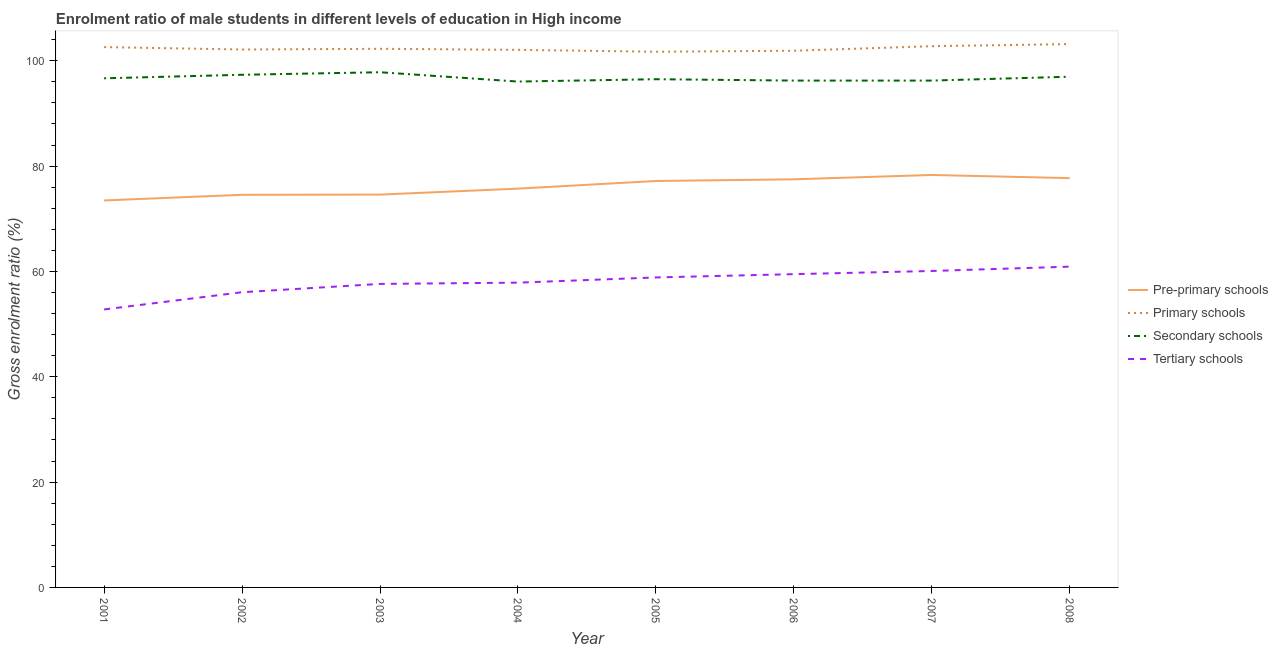Is the number of lines equal to the number of legend labels?
Provide a short and direct response. Yes. What is the gross enrolment ratio(female) in tertiary schools in 2005?
Ensure brevity in your answer.  58.86. Across all years, what is the maximum gross enrolment ratio(female) in secondary schools?
Offer a very short reply. 97.82. Across all years, what is the minimum gross enrolment ratio(female) in tertiary schools?
Your response must be concise. 52.78. In which year was the gross enrolment ratio(female) in pre-primary schools minimum?
Ensure brevity in your answer.  2001. What is the total gross enrolment ratio(female) in tertiary schools in the graph?
Make the answer very short. 463.66. What is the difference between the gross enrolment ratio(female) in pre-primary schools in 2001 and that in 2004?
Make the answer very short. -2.25. What is the difference between the gross enrolment ratio(female) in pre-primary schools in 2004 and the gross enrolment ratio(female) in secondary schools in 2003?
Your answer should be very brief. -22.1. What is the average gross enrolment ratio(female) in primary schools per year?
Make the answer very short. 102.32. In the year 2002, what is the difference between the gross enrolment ratio(female) in tertiary schools and gross enrolment ratio(female) in secondary schools?
Your response must be concise. -41.28. What is the ratio of the gross enrolment ratio(female) in secondary schools in 2001 to that in 2007?
Make the answer very short. 1. What is the difference between the highest and the second highest gross enrolment ratio(female) in secondary schools?
Ensure brevity in your answer.  0.48. What is the difference between the highest and the lowest gross enrolment ratio(female) in primary schools?
Your response must be concise. 1.45. Is it the case that in every year, the sum of the gross enrolment ratio(female) in pre-primary schools and gross enrolment ratio(female) in tertiary schools is greater than the sum of gross enrolment ratio(female) in primary schools and gross enrolment ratio(female) in secondary schools?
Make the answer very short. No. Does the gross enrolment ratio(female) in pre-primary schools monotonically increase over the years?
Provide a short and direct response. No. How many lines are there?
Your response must be concise. 4. Are the values on the major ticks of Y-axis written in scientific E-notation?
Offer a terse response. No. Where does the legend appear in the graph?
Keep it short and to the point. Center right. How many legend labels are there?
Give a very brief answer. 4. What is the title of the graph?
Ensure brevity in your answer.  Enrolment ratio of male students in different levels of education in High income. What is the label or title of the X-axis?
Your answer should be very brief. Year. What is the Gross enrolment ratio (%) in Pre-primary schools in 2001?
Provide a succinct answer. 73.47. What is the Gross enrolment ratio (%) in Primary schools in 2001?
Provide a short and direct response. 102.59. What is the Gross enrolment ratio (%) of Secondary schools in 2001?
Your answer should be very brief. 96.66. What is the Gross enrolment ratio (%) of Tertiary schools in 2001?
Your response must be concise. 52.78. What is the Gross enrolment ratio (%) in Pre-primary schools in 2002?
Provide a short and direct response. 74.55. What is the Gross enrolment ratio (%) of Primary schools in 2002?
Provide a short and direct response. 102.13. What is the Gross enrolment ratio (%) in Secondary schools in 2002?
Ensure brevity in your answer.  97.33. What is the Gross enrolment ratio (%) in Tertiary schools in 2002?
Offer a very short reply. 56.05. What is the Gross enrolment ratio (%) of Pre-primary schools in 2003?
Make the answer very short. 74.58. What is the Gross enrolment ratio (%) of Primary schools in 2003?
Provide a succinct answer. 102.27. What is the Gross enrolment ratio (%) in Secondary schools in 2003?
Give a very brief answer. 97.82. What is the Gross enrolment ratio (%) of Tertiary schools in 2003?
Your answer should be compact. 57.63. What is the Gross enrolment ratio (%) in Pre-primary schools in 2004?
Keep it short and to the point. 75.72. What is the Gross enrolment ratio (%) in Primary schools in 2004?
Offer a very short reply. 102.07. What is the Gross enrolment ratio (%) in Secondary schools in 2004?
Offer a very short reply. 96.05. What is the Gross enrolment ratio (%) in Tertiary schools in 2004?
Provide a short and direct response. 57.87. What is the Gross enrolment ratio (%) in Pre-primary schools in 2005?
Keep it short and to the point. 77.17. What is the Gross enrolment ratio (%) of Primary schools in 2005?
Offer a very short reply. 101.71. What is the Gross enrolment ratio (%) in Secondary schools in 2005?
Provide a short and direct response. 96.49. What is the Gross enrolment ratio (%) in Tertiary schools in 2005?
Offer a terse response. 58.86. What is the Gross enrolment ratio (%) in Pre-primary schools in 2006?
Make the answer very short. 77.49. What is the Gross enrolment ratio (%) of Primary schools in 2006?
Your response must be concise. 101.9. What is the Gross enrolment ratio (%) in Secondary schools in 2006?
Give a very brief answer. 96.23. What is the Gross enrolment ratio (%) in Tertiary schools in 2006?
Provide a short and direct response. 59.48. What is the Gross enrolment ratio (%) of Pre-primary schools in 2007?
Provide a short and direct response. 78.31. What is the Gross enrolment ratio (%) in Primary schools in 2007?
Offer a very short reply. 102.76. What is the Gross enrolment ratio (%) of Secondary schools in 2007?
Keep it short and to the point. 96.23. What is the Gross enrolment ratio (%) of Tertiary schools in 2007?
Make the answer very short. 60.08. What is the Gross enrolment ratio (%) in Pre-primary schools in 2008?
Offer a terse response. 77.71. What is the Gross enrolment ratio (%) of Primary schools in 2008?
Your answer should be compact. 103.16. What is the Gross enrolment ratio (%) of Secondary schools in 2008?
Ensure brevity in your answer.  96.97. What is the Gross enrolment ratio (%) of Tertiary schools in 2008?
Your answer should be compact. 60.91. Across all years, what is the maximum Gross enrolment ratio (%) of Pre-primary schools?
Provide a succinct answer. 78.31. Across all years, what is the maximum Gross enrolment ratio (%) in Primary schools?
Offer a terse response. 103.16. Across all years, what is the maximum Gross enrolment ratio (%) in Secondary schools?
Keep it short and to the point. 97.82. Across all years, what is the maximum Gross enrolment ratio (%) in Tertiary schools?
Give a very brief answer. 60.91. Across all years, what is the minimum Gross enrolment ratio (%) in Pre-primary schools?
Your answer should be compact. 73.47. Across all years, what is the minimum Gross enrolment ratio (%) of Primary schools?
Ensure brevity in your answer.  101.71. Across all years, what is the minimum Gross enrolment ratio (%) of Secondary schools?
Ensure brevity in your answer.  96.05. Across all years, what is the minimum Gross enrolment ratio (%) of Tertiary schools?
Your response must be concise. 52.78. What is the total Gross enrolment ratio (%) of Pre-primary schools in the graph?
Your answer should be compact. 609.01. What is the total Gross enrolment ratio (%) in Primary schools in the graph?
Provide a succinct answer. 818.59. What is the total Gross enrolment ratio (%) in Secondary schools in the graph?
Offer a very short reply. 773.79. What is the total Gross enrolment ratio (%) in Tertiary schools in the graph?
Your answer should be very brief. 463.66. What is the difference between the Gross enrolment ratio (%) in Pre-primary schools in 2001 and that in 2002?
Ensure brevity in your answer.  -1.07. What is the difference between the Gross enrolment ratio (%) of Primary schools in 2001 and that in 2002?
Your response must be concise. 0.46. What is the difference between the Gross enrolment ratio (%) of Secondary schools in 2001 and that in 2002?
Offer a terse response. -0.67. What is the difference between the Gross enrolment ratio (%) in Tertiary schools in 2001 and that in 2002?
Ensure brevity in your answer.  -3.27. What is the difference between the Gross enrolment ratio (%) in Pre-primary schools in 2001 and that in 2003?
Your answer should be very brief. -1.11. What is the difference between the Gross enrolment ratio (%) of Primary schools in 2001 and that in 2003?
Offer a terse response. 0.32. What is the difference between the Gross enrolment ratio (%) in Secondary schools in 2001 and that in 2003?
Keep it short and to the point. -1.15. What is the difference between the Gross enrolment ratio (%) of Tertiary schools in 2001 and that in 2003?
Ensure brevity in your answer.  -4.84. What is the difference between the Gross enrolment ratio (%) of Pre-primary schools in 2001 and that in 2004?
Your answer should be very brief. -2.25. What is the difference between the Gross enrolment ratio (%) of Primary schools in 2001 and that in 2004?
Give a very brief answer. 0.52. What is the difference between the Gross enrolment ratio (%) of Secondary schools in 2001 and that in 2004?
Keep it short and to the point. 0.62. What is the difference between the Gross enrolment ratio (%) in Tertiary schools in 2001 and that in 2004?
Provide a short and direct response. -5.08. What is the difference between the Gross enrolment ratio (%) in Pre-primary schools in 2001 and that in 2005?
Offer a very short reply. -3.69. What is the difference between the Gross enrolment ratio (%) of Primary schools in 2001 and that in 2005?
Your response must be concise. 0.88. What is the difference between the Gross enrolment ratio (%) in Secondary schools in 2001 and that in 2005?
Offer a terse response. 0.17. What is the difference between the Gross enrolment ratio (%) of Tertiary schools in 2001 and that in 2005?
Ensure brevity in your answer.  -6.07. What is the difference between the Gross enrolment ratio (%) in Pre-primary schools in 2001 and that in 2006?
Provide a short and direct response. -4.02. What is the difference between the Gross enrolment ratio (%) in Primary schools in 2001 and that in 2006?
Offer a very short reply. 0.69. What is the difference between the Gross enrolment ratio (%) in Secondary schools in 2001 and that in 2006?
Give a very brief answer. 0.43. What is the difference between the Gross enrolment ratio (%) in Tertiary schools in 2001 and that in 2006?
Your answer should be compact. -6.7. What is the difference between the Gross enrolment ratio (%) of Pre-primary schools in 2001 and that in 2007?
Offer a terse response. -4.84. What is the difference between the Gross enrolment ratio (%) in Primary schools in 2001 and that in 2007?
Make the answer very short. -0.17. What is the difference between the Gross enrolment ratio (%) in Secondary schools in 2001 and that in 2007?
Make the answer very short. 0.43. What is the difference between the Gross enrolment ratio (%) of Tertiary schools in 2001 and that in 2007?
Offer a very short reply. -7.3. What is the difference between the Gross enrolment ratio (%) in Pre-primary schools in 2001 and that in 2008?
Ensure brevity in your answer.  -4.24. What is the difference between the Gross enrolment ratio (%) of Primary schools in 2001 and that in 2008?
Provide a succinct answer. -0.57. What is the difference between the Gross enrolment ratio (%) of Secondary schools in 2001 and that in 2008?
Your answer should be very brief. -0.3. What is the difference between the Gross enrolment ratio (%) of Tertiary schools in 2001 and that in 2008?
Give a very brief answer. -8.12. What is the difference between the Gross enrolment ratio (%) in Pre-primary schools in 2002 and that in 2003?
Ensure brevity in your answer.  -0.04. What is the difference between the Gross enrolment ratio (%) in Primary schools in 2002 and that in 2003?
Make the answer very short. -0.13. What is the difference between the Gross enrolment ratio (%) in Secondary schools in 2002 and that in 2003?
Provide a short and direct response. -0.48. What is the difference between the Gross enrolment ratio (%) of Tertiary schools in 2002 and that in 2003?
Offer a terse response. -1.58. What is the difference between the Gross enrolment ratio (%) of Pre-primary schools in 2002 and that in 2004?
Give a very brief answer. -1.17. What is the difference between the Gross enrolment ratio (%) in Primary schools in 2002 and that in 2004?
Make the answer very short. 0.07. What is the difference between the Gross enrolment ratio (%) of Secondary schools in 2002 and that in 2004?
Provide a short and direct response. 1.29. What is the difference between the Gross enrolment ratio (%) of Tertiary schools in 2002 and that in 2004?
Provide a short and direct response. -1.82. What is the difference between the Gross enrolment ratio (%) of Pre-primary schools in 2002 and that in 2005?
Ensure brevity in your answer.  -2.62. What is the difference between the Gross enrolment ratio (%) in Primary schools in 2002 and that in 2005?
Keep it short and to the point. 0.42. What is the difference between the Gross enrolment ratio (%) of Secondary schools in 2002 and that in 2005?
Offer a very short reply. 0.84. What is the difference between the Gross enrolment ratio (%) in Tertiary schools in 2002 and that in 2005?
Keep it short and to the point. -2.81. What is the difference between the Gross enrolment ratio (%) of Pre-primary schools in 2002 and that in 2006?
Offer a terse response. -2.94. What is the difference between the Gross enrolment ratio (%) in Primary schools in 2002 and that in 2006?
Give a very brief answer. 0.23. What is the difference between the Gross enrolment ratio (%) in Secondary schools in 2002 and that in 2006?
Keep it short and to the point. 1.1. What is the difference between the Gross enrolment ratio (%) in Tertiary schools in 2002 and that in 2006?
Ensure brevity in your answer.  -3.43. What is the difference between the Gross enrolment ratio (%) of Pre-primary schools in 2002 and that in 2007?
Your response must be concise. -3.76. What is the difference between the Gross enrolment ratio (%) in Primary schools in 2002 and that in 2007?
Ensure brevity in your answer.  -0.63. What is the difference between the Gross enrolment ratio (%) of Secondary schools in 2002 and that in 2007?
Give a very brief answer. 1.1. What is the difference between the Gross enrolment ratio (%) in Tertiary schools in 2002 and that in 2007?
Make the answer very short. -4.03. What is the difference between the Gross enrolment ratio (%) of Pre-primary schools in 2002 and that in 2008?
Provide a short and direct response. -3.16. What is the difference between the Gross enrolment ratio (%) in Primary schools in 2002 and that in 2008?
Provide a short and direct response. -1.03. What is the difference between the Gross enrolment ratio (%) of Secondary schools in 2002 and that in 2008?
Ensure brevity in your answer.  0.37. What is the difference between the Gross enrolment ratio (%) in Tertiary schools in 2002 and that in 2008?
Ensure brevity in your answer.  -4.86. What is the difference between the Gross enrolment ratio (%) of Pre-primary schools in 2003 and that in 2004?
Ensure brevity in your answer.  -1.14. What is the difference between the Gross enrolment ratio (%) in Primary schools in 2003 and that in 2004?
Provide a short and direct response. 0.2. What is the difference between the Gross enrolment ratio (%) in Secondary schools in 2003 and that in 2004?
Make the answer very short. 1.77. What is the difference between the Gross enrolment ratio (%) of Tertiary schools in 2003 and that in 2004?
Keep it short and to the point. -0.24. What is the difference between the Gross enrolment ratio (%) in Pre-primary schools in 2003 and that in 2005?
Provide a succinct answer. -2.58. What is the difference between the Gross enrolment ratio (%) in Primary schools in 2003 and that in 2005?
Offer a very short reply. 0.56. What is the difference between the Gross enrolment ratio (%) in Secondary schools in 2003 and that in 2005?
Offer a very short reply. 1.32. What is the difference between the Gross enrolment ratio (%) in Tertiary schools in 2003 and that in 2005?
Your response must be concise. -1.23. What is the difference between the Gross enrolment ratio (%) in Pre-primary schools in 2003 and that in 2006?
Provide a succinct answer. -2.91. What is the difference between the Gross enrolment ratio (%) of Primary schools in 2003 and that in 2006?
Your response must be concise. 0.37. What is the difference between the Gross enrolment ratio (%) in Secondary schools in 2003 and that in 2006?
Provide a succinct answer. 1.58. What is the difference between the Gross enrolment ratio (%) in Tertiary schools in 2003 and that in 2006?
Keep it short and to the point. -1.85. What is the difference between the Gross enrolment ratio (%) in Pre-primary schools in 2003 and that in 2007?
Offer a very short reply. -3.73. What is the difference between the Gross enrolment ratio (%) in Primary schools in 2003 and that in 2007?
Make the answer very short. -0.49. What is the difference between the Gross enrolment ratio (%) of Secondary schools in 2003 and that in 2007?
Your response must be concise. 1.58. What is the difference between the Gross enrolment ratio (%) of Tertiary schools in 2003 and that in 2007?
Give a very brief answer. -2.46. What is the difference between the Gross enrolment ratio (%) of Pre-primary schools in 2003 and that in 2008?
Offer a very short reply. -3.13. What is the difference between the Gross enrolment ratio (%) in Primary schools in 2003 and that in 2008?
Give a very brief answer. -0.89. What is the difference between the Gross enrolment ratio (%) in Secondary schools in 2003 and that in 2008?
Offer a very short reply. 0.85. What is the difference between the Gross enrolment ratio (%) in Tertiary schools in 2003 and that in 2008?
Your answer should be compact. -3.28. What is the difference between the Gross enrolment ratio (%) of Pre-primary schools in 2004 and that in 2005?
Your answer should be very brief. -1.45. What is the difference between the Gross enrolment ratio (%) in Primary schools in 2004 and that in 2005?
Keep it short and to the point. 0.36. What is the difference between the Gross enrolment ratio (%) of Secondary schools in 2004 and that in 2005?
Offer a terse response. -0.45. What is the difference between the Gross enrolment ratio (%) in Tertiary schools in 2004 and that in 2005?
Offer a very short reply. -0.99. What is the difference between the Gross enrolment ratio (%) of Pre-primary schools in 2004 and that in 2006?
Your response must be concise. -1.77. What is the difference between the Gross enrolment ratio (%) of Primary schools in 2004 and that in 2006?
Offer a terse response. 0.17. What is the difference between the Gross enrolment ratio (%) of Secondary schools in 2004 and that in 2006?
Keep it short and to the point. -0.19. What is the difference between the Gross enrolment ratio (%) of Tertiary schools in 2004 and that in 2006?
Provide a succinct answer. -1.61. What is the difference between the Gross enrolment ratio (%) in Pre-primary schools in 2004 and that in 2007?
Provide a succinct answer. -2.59. What is the difference between the Gross enrolment ratio (%) in Primary schools in 2004 and that in 2007?
Ensure brevity in your answer.  -0.7. What is the difference between the Gross enrolment ratio (%) of Secondary schools in 2004 and that in 2007?
Ensure brevity in your answer.  -0.19. What is the difference between the Gross enrolment ratio (%) in Tertiary schools in 2004 and that in 2007?
Offer a very short reply. -2.22. What is the difference between the Gross enrolment ratio (%) in Pre-primary schools in 2004 and that in 2008?
Give a very brief answer. -1.99. What is the difference between the Gross enrolment ratio (%) of Primary schools in 2004 and that in 2008?
Your response must be concise. -1.1. What is the difference between the Gross enrolment ratio (%) of Secondary schools in 2004 and that in 2008?
Offer a terse response. -0.92. What is the difference between the Gross enrolment ratio (%) in Tertiary schools in 2004 and that in 2008?
Keep it short and to the point. -3.04. What is the difference between the Gross enrolment ratio (%) of Pre-primary schools in 2005 and that in 2006?
Make the answer very short. -0.32. What is the difference between the Gross enrolment ratio (%) in Primary schools in 2005 and that in 2006?
Offer a very short reply. -0.19. What is the difference between the Gross enrolment ratio (%) of Secondary schools in 2005 and that in 2006?
Provide a succinct answer. 0.26. What is the difference between the Gross enrolment ratio (%) in Tertiary schools in 2005 and that in 2006?
Provide a succinct answer. -0.62. What is the difference between the Gross enrolment ratio (%) of Pre-primary schools in 2005 and that in 2007?
Give a very brief answer. -1.14. What is the difference between the Gross enrolment ratio (%) of Primary schools in 2005 and that in 2007?
Offer a very short reply. -1.05. What is the difference between the Gross enrolment ratio (%) in Secondary schools in 2005 and that in 2007?
Provide a succinct answer. 0.26. What is the difference between the Gross enrolment ratio (%) of Tertiary schools in 2005 and that in 2007?
Give a very brief answer. -1.23. What is the difference between the Gross enrolment ratio (%) in Pre-primary schools in 2005 and that in 2008?
Your response must be concise. -0.54. What is the difference between the Gross enrolment ratio (%) in Primary schools in 2005 and that in 2008?
Your answer should be compact. -1.45. What is the difference between the Gross enrolment ratio (%) of Secondary schools in 2005 and that in 2008?
Your answer should be very brief. -0.48. What is the difference between the Gross enrolment ratio (%) in Tertiary schools in 2005 and that in 2008?
Make the answer very short. -2.05. What is the difference between the Gross enrolment ratio (%) of Pre-primary schools in 2006 and that in 2007?
Give a very brief answer. -0.82. What is the difference between the Gross enrolment ratio (%) of Primary schools in 2006 and that in 2007?
Ensure brevity in your answer.  -0.86. What is the difference between the Gross enrolment ratio (%) of Secondary schools in 2006 and that in 2007?
Provide a succinct answer. -0. What is the difference between the Gross enrolment ratio (%) of Tertiary schools in 2006 and that in 2007?
Ensure brevity in your answer.  -0.6. What is the difference between the Gross enrolment ratio (%) of Pre-primary schools in 2006 and that in 2008?
Offer a terse response. -0.22. What is the difference between the Gross enrolment ratio (%) of Primary schools in 2006 and that in 2008?
Your answer should be compact. -1.26. What is the difference between the Gross enrolment ratio (%) of Secondary schools in 2006 and that in 2008?
Your response must be concise. -0.74. What is the difference between the Gross enrolment ratio (%) in Tertiary schools in 2006 and that in 2008?
Ensure brevity in your answer.  -1.43. What is the difference between the Gross enrolment ratio (%) in Pre-primary schools in 2007 and that in 2008?
Make the answer very short. 0.6. What is the difference between the Gross enrolment ratio (%) of Primary schools in 2007 and that in 2008?
Your answer should be compact. -0.4. What is the difference between the Gross enrolment ratio (%) in Secondary schools in 2007 and that in 2008?
Ensure brevity in your answer.  -0.73. What is the difference between the Gross enrolment ratio (%) of Tertiary schools in 2007 and that in 2008?
Offer a terse response. -0.82. What is the difference between the Gross enrolment ratio (%) of Pre-primary schools in 2001 and the Gross enrolment ratio (%) of Primary schools in 2002?
Your answer should be compact. -28.66. What is the difference between the Gross enrolment ratio (%) in Pre-primary schools in 2001 and the Gross enrolment ratio (%) in Secondary schools in 2002?
Keep it short and to the point. -23.86. What is the difference between the Gross enrolment ratio (%) in Pre-primary schools in 2001 and the Gross enrolment ratio (%) in Tertiary schools in 2002?
Make the answer very short. 17.42. What is the difference between the Gross enrolment ratio (%) of Primary schools in 2001 and the Gross enrolment ratio (%) of Secondary schools in 2002?
Your answer should be compact. 5.25. What is the difference between the Gross enrolment ratio (%) of Primary schools in 2001 and the Gross enrolment ratio (%) of Tertiary schools in 2002?
Provide a succinct answer. 46.54. What is the difference between the Gross enrolment ratio (%) of Secondary schools in 2001 and the Gross enrolment ratio (%) of Tertiary schools in 2002?
Your answer should be very brief. 40.61. What is the difference between the Gross enrolment ratio (%) in Pre-primary schools in 2001 and the Gross enrolment ratio (%) in Primary schools in 2003?
Give a very brief answer. -28.79. What is the difference between the Gross enrolment ratio (%) of Pre-primary schools in 2001 and the Gross enrolment ratio (%) of Secondary schools in 2003?
Give a very brief answer. -24.34. What is the difference between the Gross enrolment ratio (%) in Pre-primary schools in 2001 and the Gross enrolment ratio (%) in Tertiary schools in 2003?
Ensure brevity in your answer.  15.85. What is the difference between the Gross enrolment ratio (%) in Primary schools in 2001 and the Gross enrolment ratio (%) in Secondary schools in 2003?
Make the answer very short. 4.77. What is the difference between the Gross enrolment ratio (%) of Primary schools in 2001 and the Gross enrolment ratio (%) of Tertiary schools in 2003?
Offer a very short reply. 44.96. What is the difference between the Gross enrolment ratio (%) of Secondary schools in 2001 and the Gross enrolment ratio (%) of Tertiary schools in 2003?
Provide a succinct answer. 39.04. What is the difference between the Gross enrolment ratio (%) of Pre-primary schools in 2001 and the Gross enrolment ratio (%) of Primary schools in 2004?
Your response must be concise. -28.59. What is the difference between the Gross enrolment ratio (%) in Pre-primary schools in 2001 and the Gross enrolment ratio (%) in Secondary schools in 2004?
Keep it short and to the point. -22.57. What is the difference between the Gross enrolment ratio (%) of Pre-primary schools in 2001 and the Gross enrolment ratio (%) of Tertiary schools in 2004?
Ensure brevity in your answer.  15.61. What is the difference between the Gross enrolment ratio (%) in Primary schools in 2001 and the Gross enrolment ratio (%) in Secondary schools in 2004?
Make the answer very short. 6.54. What is the difference between the Gross enrolment ratio (%) in Primary schools in 2001 and the Gross enrolment ratio (%) in Tertiary schools in 2004?
Give a very brief answer. 44.72. What is the difference between the Gross enrolment ratio (%) in Secondary schools in 2001 and the Gross enrolment ratio (%) in Tertiary schools in 2004?
Provide a succinct answer. 38.8. What is the difference between the Gross enrolment ratio (%) of Pre-primary schools in 2001 and the Gross enrolment ratio (%) of Primary schools in 2005?
Make the answer very short. -28.23. What is the difference between the Gross enrolment ratio (%) in Pre-primary schools in 2001 and the Gross enrolment ratio (%) in Secondary schools in 2005?
Keep it short and to the point. -23.02. What is the difference between the Gross enrolment ratio (%) in Pre-primary schools in 2001 and the Gross enrolment ratio (%) in Tertiary schools in 2005?
Your response must be concise. 14.62. What is the difference between the Gross enrolment ratio (%) of Primary schools in 2001 and the Gross enrolment ratio (%) of Secondary schools in 2005?
Provide a short and direct response. 6.1. What is the difference between the Gross enrolment ratio (%) in Primary schools in 2001 and the Gross enrolment ratio (%) in Tertiary schools in 2005?
Provide a succinct answer. 43.73. What is the difference between the Gross enrolment ratio (%) of Secondary schools in 2001 and the Gross enrolment ratio (%) of Tertiary schools in 2005?
Provide a succinct answer. 37.81. What is the difference between the Gross enrolment ratio (%) in Pre-primary schools in 2001 and the Gross enrolment ratio (%) in Primary schools in 2006?
Ensure brevity in your answer.  -28.42. What is the difference between the Gross enrolment ratio (%) of Pre-primary schools in 2001 and the Gross enrolment ratio (%) of Secondary schools in 2006?
Give a very brief answer. -22.76. What is the difference between the Gross enrolment ratio (%) of Pre-primary schools in 2001 and the Gross enrolment ratio (%) of Tertiary schools in 2006?
Offer a terse response. 13.99. What is the difference between the Gross enrolment ratio (%) in Primary schools in 2001 and the Gross enrolment ratio (%) in Secondary schools in 2006?
Keep it short and to the point. 6.36. What is the difference between the Gross enrolment ratio (%) of Primary schools in 2001 and the Gross enrolment ratio (%) of Tertiary schools in 2006?
Offer a terse response. 43.11. What is the difference between the Gross enrolment ratio (%) in Secondary schools in 2001 and the Gross enrolment ratio (%) in Tertiary schools in 2006?
Your response must be concise. 37.18. What is the difference between the Gross enrolment ratio (%) of Pre-primary schools in 2001 and the Gross enrolment ratio (%) of Primary schools in 2007?
Offer a very short reply. -29.29. What is the difference between the Gross enrolment ratio (%) of Pre-primary schools in 2001 and the Gross enrolment ratio (%) of Secondary schools in 2007?
Offer a very short reply. -22.76. What is the difference between the Gross enrolment ratio (%) of Pre-primary schools in 2001 and the Gross enrolment ratio (%) of Tertiary schools in 2007?
Your answer should be compact. 13.39. What is the difference between the Gross enrolment ratio (%) in Primary schools in 2001 and the Gross enrolment ratio (%) in Secondary schools in 2007?
Offer a very short reply. 6.36. What is the difference between the Gross enrolment ratio (%) in Primary schools in 2001 and the Gross enrolment ratio (%) in Tertiary schools in 2007?
Make the answer very short. 42.51. What is the difference between the Gross enrolment ratio (%) in Secondary schools in 2001 and the Gross enrolment ratio (%) in Tertiary schools in 2007?
Keep it short and to the point. 36.58. What is the difference between the Gross enrolment ratio (%) in Pre-primary schools in 2001 and the Gross enrolment ratio (%) in Primary schools in 2008?
Offer a terse response. -29.69. What is the difference between the Gross enrolment ratio (%) in Pre-primary schools in 2001 and the Gross enrolment ratio (%) in Secondary schools in 2008?
Provide a short and direct response. -23.49. What is the difference between the Gross enrolment ratio (%) of Pre-primary schools in 2001 and the Gross enrolment ratio (%) of Tertiary schools in 2008?
Provide a short and direct response. 12.57. What is the difference between the Gross enrolment ratio (%) of Primary schools in 2001 and the Gross enrolment ratio (%) of Secondary schools in 2008?
Keep it short and to the point. 5.62. What is the difference between the Gross enrolment ratio (%) of Primary schools in 2001 and the Gross enrolment ratio (%) of Tertiary schools in 2008?
Make the answer very short. 41.68. What is the difference between the Gross enrolment ratio (%) in Secondary schools in 2001 and the Gross enrolment ratio (%) in Tertiary schools in 2008?
Offer a very short reply. 35.76. What is the difference between the Gross enrolment ratio (%) of Pre-primary schools in 2002 and the Gross enrolment ratio (%) of Primary schools in 2003?
Give a very brief answer. -27.72. What is the difference between the Gross enrolment ratio (%) of Pre-primary schools in 2002 and the Gross enrolment ratio (%) of Secondary schools in 2003?
Provide a short and direct response. -23.27. What is the difference between the Gross enrolment ratio (%) in Pre-primary schools in 2002 and the Gross enrolment ratio (%) in Tertiary schools in 2003?
Offer a very short reply. 16.92. What is the difference between the Gross enrolment ratio (%) of Primary schools in 2002 and the Gross enrolment ratio (%) of Secondary schools in 2003?
Your answer should be compact. 4.32. What is the difference between the Gross enrolment ratio (%) in Primary schools in 2002 and the Gross enrolment ratio (%) in Tertiary schools in 2003?
Offer a very short reply. 44.51. What is the difference between the Gross enrolment ratio (%) in Secondary schools in 2002 and the Gross enrolment ratio (%) in Tertiary schools in 2003?
Keep it short and to the point. 39.71. What is the difference between the Gross enrolment ratio (%) of Pre-primary schools in 2002 and the Gross enrolment ratio (%) of Primary schools in 2004?
Ensure brevity in your answer.  -27.52. What is the difference between the Gross enrolment ratio (%) in Pre-primary schools in 2002 and the Gross enrolment ratio (%) in Secondary schools in 2004?
Your response must be concise. -21.5. What is the difference between the Gross enrolment ratio (%) in Pre-primary schools in 2002 and the Gross enrolment ratio (%) in Tertiary schools in 2004?
Make the answer very short. 16.68. What is the difference between the Gross enrolment ratio (%) of Primary schools in 2002 and the Gross enrolment ratio (%) of Secondary schools in 2004?
Make the answer very short. 6.09. What is the difference between the Gross enrolment ratio (%) in Primary schools in 2002 and the Gross enrolment ratio (%) in Tertiary schools in 2004?
Give a very brief answer. 44.27. What is the difference between the Gross enrolment ratio (%) of Secondary schools in 2002 and the Gross enrolment ratio (%) of Tertiary schools in 2004?
Provide a succinct answer. 39.47. What is the difference between the Gross enrolment ratio (%) in Pre-primary schools in 2002 and the Gross enrolment ratio (%) in Primary schools in 2005?
Your answer should be very brief. -27.16. What is the difference between the Gross enrolment ratio (%) in Pre-primary schools in 2002 and the Gross enrolment ratio (%) in Secondary schools in 2005?
Your answer should be very brief. -21.95. What is the difference between the Gross enrolment ratio (%) of Pre-primary schools in 2002 and the Gross enrolment ratio (%) of Tertiary schools in 2005?
Provide a succinct answer. 15.69. What is the difference between the Gross enrolment ratio (%) in Primary schools in 2002 and the Gross enrolment ratio (%) in Secondary schools in 2005?
Your answer should be compact. 5.64. What is the difference between the Gross enrolment ratio (%) in Primary schools in 2002 and the Gross enrolment ratio (%) in Tertiary schools in 2005?
Offer a terse response. 43.28. What is the difference between the Gross enrolment ratio (%) of Secondary schools in 2002 and the Gross enrolment ratio (%) of Tertiary schools in 2005?
Your answer should be very brief. 38.48. What is the difference between the Gross enrolment ratio (%) in Pre-primary schools in 2002 and the Gross enrolment ratio (%) in Primary schools in 2006?
Offer a very short reply. -27.35. What is the difference between the Gross enrolment ratio (%) in Pre-primary schools in 2002 and the Gross enrolment ratio (%) in Secondary schools in 2006?
Provide a succinct answer. -21.69. What is the difference between the Gross enrolment ratio (%) of Pre-primary schools in 2002 and the Gross enrolment ratio (%) of Tertiary schools in 2006?
Offer a terse response. 15.07. What is the difference between the Gross enrolment ratio (%) of Primary schools in 2002 and the Gross enrolment ratio (%) of Secondary schools in 2006?
Provide a succinct answer. 5.9. What is the difference between the Gross enrolment ratio (%) of Primary schools in 2002 and the Gross enrolment ratio (%) of Tertiary schools in 2006?
Provide a short and direct response. 42.65. What is the difference between the Gross enrolment ratio (%) in Secondary schools in 2002 and the Gross enrolment ratio (%) in Tertiary schools in 2006?
Make the answer very short. 37.85. What is the difference between the Gross enrolment ratio (%) in Pre-primary schools in 2002 and the Gross enrolment ratio (%) in Primary schools in 2007?
Your response must be concise. -28.22. What is the difference between the Gross enrolment ratio (%) in Pre-primary schools in 2002 and the Gross enrolment ratio (%) in Secondary schools in 2007?
Offer a terse response. -21.69. What is the difference between the Gross enrolment ratio (%) of Pre-primary schools in 2002 and the Gross enrolment ratio (%) of Tertiary schools in 2007?
Offer a terse response. 14.46. What is the difference between the Gross enrolment ratio (%) in Primary schools in 2002 and the Gross enrolment ratio (%) in Secondary schools in 2007?
Give a very brief answer. 5.9. What is the difference between the Gross enrolment ratio (%) in Primary schools in 2002 and the Gross enrolment ratio (%) in Tertiary schools in 2007?
Keep it short and to the point. 42.05. What is the difference between the Gross enrolment ratio (%) in Secondary schools in 2002 and the Gross enrolment ratio (%) in Tertiary schools in 2007?
Your answer should be very brief. 37.25. What is the difference between the Gross enrolment ratio (%) of Pre-primary schools in 2002 and the Gross enrolment ratio (%) of Primary schools in 2008?
Your response must be concise. -28.61. What is the difference between the Gross enrolment ratio (%) of Pre-primary schools in 2002 and the Gross enrolment ratio (%) of Secondary schools in 2008?
Your answer should be very brief. -22.42. What is the difference between the Gross enrolment ratio (%) in Pre-primary schools in 2002 and the Gross enrolment ratio (%) in Tertiary schools in 2008?
Ensure brevity in your answer.  13.64. What is the difference between the Gross enrolment ratio (%) in Primary schools in 2002 and the Gross enrolment ratio (%) in Secondary schools in 2008?
Your answer should be very brief. 5.16. What is the difference between the Gross enrolment ratio (%) in Primary schools in 2002 and the Gross enrolment ratio (%) in Tertiary schools in 2008?
Your answer should be compact. 41.23. What is the difference between the Gross enrolment ratio (%) of Secondary schools in 2002 and the Gross enrolment ratio (%) of Tertiary schools in 2008?
Your response must be concise. 36.43. What is the difference between the Gross enrolment ratio (%) of Pre-primary schools in 2003 and the Gross enrolment ratio (%) of Primary schools in 2004?
Provide a succinct answer. -27.48. What is the difference between the Gross enrolment ratio (%) in Pre-primary schools in 2003 and the Gross enrolment ratio (%) in Secondary schools in 2004?
Provide a succinct answer. -21.46. What is the difference between the Gross enrolment ratio (%) in Pre-primary schools in 2003 and the Gross enrolment ratio (%) in Tertiary schools in 2004?
Your answer should be very brief. 16.72. What is the difference between the Gross enrolment ratio (%) in Primary schools in 2003 and the Gross enrolment ratio (%) in Secondary schools in 2004?
Provide a succinct answer. 6.22. What is the difference between the Gross enrolment ratio (%) of Primary schools in 2003 and the Gross enrolment ratio (%) of Tertiary schools in 2004?
Offer a terse response. 44.4. What is the difference between the Gross enrolment ratio (%) of Secondary schools in 2003 and the Gross enrolment ratio (%) of Tertiary schools in 2004?
Make the answer very short. 39.95. What is the difference between the Gross enrolment ratio (%) in Pre-primary schools in 2003 and the Gross enrolment ratio (%) in Primary schools in 2005?
Offer a very short reply. -27.12. What is the difference between the Gross enrolment ratio (%) in Pre-primary schools in 2003 and the Gross enrolment ratio (%) in Secondary schools in 2005?
Give a very brief answer. -21.91. What is the difference between the Gross enrolment ratio (%) of Pre-primary schools in 2003 and the Gross enrolment ratio (%) of Tertiary schools in 2005?
Provide a succinct answer. 15.73. What is the difference between the Gross enrolment ratio (%) in Primary schools in 2003 and the Gross enrolment ratio (%) in Secondary schools in 2005?
Keep it short and to the point. 5.78. What is the difference between the Gross enrolment ratio (%) of Primary schools in 2003 and the Gross enrolment ratio (%) of Tertiary schools in 2005?
Your answer should be compact. 43.41. What is the difference between the Gross enrolment ratio (%) in Secondary schools in 2003 and the Gross enrolment ratio (%) in Tertiary schools in 2005?
Offer a very short reply. 38.96. What is the difference between the Gross enrolment ratio (%) of Pre-primary schools in 2003 and the Gross enrolment ratio (%) of Primary schools in 2006?
Your answer should be compact. -27.31. What is the difference between the Gross enrolment ratio (%) in Pre-primary schools in 2003 and the Gross enrolment ratio (%) in Secondary schools in 2006?
Offer a very short reply. -21.65. What is the difference between the Gross enrolment ratio (%) of Pre-primary schools in 2003 and the Gross enrolment ratio (%) of Tertiary schools in 2006?
Give a very brief answer. 15.1. What is the difference between the Gross enrolment ratio (%) of Primary schools in 2003 and the Gross enrolment ratio (%) of Secondary schools in 2006?
Offer a very short reply. 6.04. What is the difference between the Gross enrolment ratio (%) in Primary schools in 2003 and the Gross enrolment ratio (%) in Tertiary schools in 2006?
Ensure brevity in your answer.  42.79. What is the difference between the Gross enrolment ratio (%) in Secondary schools in 2003 and the Gross enrolment ratio (%) in Tertiary schools in 2006?
Provide a succinct answer. 38.34. What is the difference between the Gross enrolment ratio (%) in Pre-primary schools in 2003 and the Gross enrolment ratio (%) in Primary schools in 2007?
Make the answer very short. -28.18. What is the difference between the Gross enrolment ratio (%) of Pre-primary schools in 2003 and the Gross enrolment ratio (%) of Secondary schools in 2007?
Keep it short and to the point. -21.65. What is the difference between the Gross enrolment ratio (%) in Pre-primary schools in 2003 and the Gross enrolment ratio (%) in Tertiary schools in 2007?
Give a very brief answer. 14.5. What is the difference between the Gross enrolment ratio (%) in Primary schools in 2003 and the Gross enrolment ratio (%) in Secondary schools in 2007?
Your answer should be very brief. 6.03. What is the difference between the Gross enrolment ratio (%) of Primary schools in 2003 and the Gross enrolment ratio (%) of Tertiary schools in 2007?
Offer a terse response. 42.18. What is the difference between the Gross enrolment ratio (%) of Secondary schools in 2003 and the Gross enrolment ratio (%) of Tertiary schools in 2007?
Provide a short and direct response. 37.73. What is the difference between the Gross enrolment ratio (%) of Pre-primary schools in 2003 and the Gross enrolment ratio (%) of Primary schools in 2008?
Ensure brevity in your answer.  -28.58. What is the difference between the Gross enrolment ratio (%) in Pre-primary schools in 2003 and the Gross enrolment ratio (%) in Secondary schools in 2008?
Offer a very short reply. -22.38. What is the difference between the Gross enrolment ratio (%) of Pre-primary schools in 2003 and the Gross enrolment ratio (%) of Tertiary schools in 2008?
Offer a terse response. 13.68. What is the difference between the Gross enrolment ratio (%) in Primary schools in 2003 and the Gross enrolment ratio (%) in Secondary schools in 2008?
Ensure brevity in your answer.  5.3. What is the difference between the Gross enrolment ratio (%) in Primary schools in 2003 and the Gross enrolment ratio (%) in Tertiary schools in 2008?
Your answer should be very brief. 41.36. What is the difference between the Gross enrolment ratio (%) in Secondary schools in 2003 and the Gross enrolment ratio (%) in Tertiary schools in 2008?
Make the answer very short. 36.91. What is the difference between the Gross enrolment ratio (%) of Pre-primary schools in 2004 and the Gross enrolment ratio (%) of Primary schools in 2005?
Offer a very short reply. -25.99. What is the difference between the Gross enrolment ratio (%) of Pre-primary schools in 2004 and the Gross enrolment ratio (%) of Secondary schools in 2005?
Keep it short and to the point. -20.77. What is the difference between the Gross enrolment ratio (%) of Pre-primary schools in 2004 and the Gross enrolment ratio (%) of Tertiary schools in 2005?
Your response must be concise. 16.86. What is the difference between the Gross enrolment ratio (%) of Primary schools in 2004 and the Gross enrolment ratio (%) of Secondary schools in 2005?
Provide a succinct answer. 5.57. What is the difference between the Gross enrolment ratio (%) of Primary schools in 2004 and the Gross enrolment ratio (%) of Tertiary schools in 2005?
Offer a terse response. 43.21. What is the difference between the Gross enrolment ratio (%) in Secondary schools in 2004 and the Gross enrolment ratio (%) in Tertiary schools in 2005?
Make the answer very short. 37.19. What is the difference between the Gross enrolment ratio (%) of Pre-primary schools in 2004 and the Gross enrolment ratio (%) of Primary schools in 2006?
Give a very brief answer. -26.18. What is the difference between the Gross enrolment ratio (%) in Pre-primary schools in 2004 and the Gross enrolment ratio (%) in Secondary schools in 2006?
Provide a short and direct response. -20.51. What is the difference between the Gross enrolment ratio (%) of Pre-primary schools in 2004 and the Gross enrolment ratio (%) of Tertiary schools in 2006?
Keep it short and to the point. 16.24. What is the difference between the Gross enrolment ratio (%) of Primary schools in 2004 and the Gross enrolment ratio (%) of Secondary schools in 2006?
Keep it short and to the point. 5.83. What is the difference between the Gross enrolment ratio (%) in Primary schools in 2004 and the Gross enrolment ratio (%) in Tertiary schools in 2006?
Keep it short and to the point. 42.59. What is the difference between the Gross enrolment ratio (%) of Secondary schools in 2004 and the Gross enrolment ratio (%) of Tertiary schools in 2006?
Your answer should be very brief. 36.57. What is the difference between the Gross enrolment ratio (%) of Pre-primary schools in 2004 and the Gross enrolment ratio (%) of Primary schools in 2007?
Make the answer very short. -27.04. What is the difference between the Gross enrolment ratio (%) of Pre-primary schools in 2004 and the Gross enrolment ratio (%) of Secondary schools in 2007?
Make the answer very short. -20.51. What is the difference between the Gross enrolment ratio (%) in Pre-primary schools in 2004 and the Gross enrolment ratio (%) in Tertiary schools in 2007?
Provide a succinct answer. 15.64. What is the difference between the Gross enrolment ratio (%) of Primary schools in 2004 and the Gross enrolment ratio (%) of Secondary schools in 2007?
Keep it short and to the point. 5.83. What is the difference between the Gross enrolment ratio (%) of Primary schools in 2004 and the Gross enrolment ratio (%) of Tertiary schools in 2007?
Provide a succinct answer. 41.98. What is the difference between the Gross enrolment ratio (%) of Secondary schools in 2004 and the Gross enrolment ratio (%) of Tertiary schools in 2007?
Offer a terse response. 35.96. What is the difference between the Gross enrolment ratio (%) in Pre-primary schools in 2004 and the Gross enrolment ratio (%) in Primary schools in 2008?
Offer a very short reply. -27.44. What is the difference between the Gross enrolment ratio (%) of Pre-primary schools in 2004 and the Gross enrolment ratio (%) of Secondary schools in 2008?
Offer a terse response. -21.25. What is the difference between the Gross enrolment ratio (%) of Pre-primary schools in 2004 and the Gross enrolment ratio (%) of Tertiary schools in 2008?
Provide a short and direct response. 14.81. What is the difference between the Gross enrolment ratio (%) in Primary schools in 2004 and the Gross enrolment ratio (%) in Secondary schools in 2008?
Your answer should be compact. 5.1. What is the difference between the Gross enrolment ratio (%) in Primary schools in 2004 and the Gross enrolment ratio (%) in Tertiary schools in 2008?
Offer a very short reply. 41.16. What is the difference between the Gross enrolment ratio (%) of Secondary schools in 2004 and the Gross enrolment ratio (%) of Tertiary schools in 2008?
Provide a succinct answer. 35.14. What is the difference between the Gross enrolment ratio (%) in Pre-primary schools in 2005 and the Gross enrolment ratio (%) in Primary schools in 2006?
Give a very brief answer. -24.73. What is the difference between the Gross enrolment ratio (%) in Pre-primary schools in 2005 and the Gross enrolment ratio (%) in Secondary schools in 2006?
Offer a terse response. -19.06. What is the difference between the Gross enrolment ratio (%) of Pre-primary schools in 2005 and the Gross enrolment ratio (%) of Tertiary schools in 2006?
Make the answer very short. 17.69. What is the difference between the Gross enrolment ratio (%) of Primary schools in 2005 and the Gross enrolment ratio (%) of Secondary schools in 2006?
Ensure brevity in your answer.  5.48. What is the difference between the Gross enrolment ratio (%) of Primary schools in 2005 and the Gross enrolment ratio (%) of Tertiary schools in 2006?
Your answer should be very brief. 42.23. What is the difference between the Gross enrolment ratio (%) of Secondary schools in 2005 and the Gross enrolment ratio (%) of Tertiary schools in 2006?
Offer a very short reply. 37.01. What is the difference between the Gross enrolment ratio (%) in Pre-primary schools in 2005 and the Gross enrolment ratio (%) in Primary schools in 2007?
Provide a short and direct response. -25.59. What is the difference between the Gross enrolment ratio (%) of Pre-primary schools in 2005 and the Gross enrolment ratio (%) of Secondary schools in 2007?
Provide a succinct answer. -19.07. What is the difference between the Gross enrolment ratio (%) of Pre-primary schools in 2005 and the Gross enrolment ratio (%) of Tertiary schools in 2007?
Provide a short and direct response. 17.08. What is the difference between the Gross enrolment ratio (%) in Primary schools in 2005 and the Gross enrolment ratio (%) in Secondary schools in 2007?
Make the answer very short. 5.47. What is the difference between the Gross enrolment ratio (%) in Primary schools in 2005 and the Gross enrolment ratio (%) in Tertiary schools in 2007?
Your answer should be very brief. 41.63. What is the difference between the Gross enrolment ratio (%) of Secondary schools in 2005 and the Gross enrolment ratio (%) of Tertiary schools in 2007?
Your answer should be very brief. 36.41. What is the difference between the Gross enrolment ratio (%) in Pre-primary schools in 2005 and the Gross enrolment ratio (%) in Primary schools in 2008?
Your answer should be very brief. -25.99. What is the difference between the Gross enrolment ratio (%) in Pre-primary schools in 2005 and the Gross enrolment ratio (%) in Secondary schools in 2008?
Ensure brevity in your answer.  -19.8. What is the difference between the Gross enrolment ratio (%) of Pre-primary schools in 2005 and the Gross enrolment ratio (%) of Tertiary schools in 2008?
Provide a succinct answer. 16.26. What is the difference between the Gross enrolment ratio (%) in Primary schools in 2005 and the Gross enrolment ratio (%) in Secondary schools in 2008?
Your answer should be very brief. 4.74. What is the difference between the Gross enrolment ratio (%) in Primary schools in 2005 and the Gross enrolment ratio (%) in Tertiary schools in 2008?
Provide a succinct answer. 40.8. What is the difference between the Gross enrolment ratio (%) of Secondary schools in 2005 and the Gross enrolment ratio (%) of Tertiary schools in 2008?
Your answer should be very brief. 35.59. What is the difference between the Gross enrolment ratio (%) in Pre-primary schools in 2006 and the Gross enrolment ratio (%) in Primary schools in 2007?
Keep it short and to the point. -25.27. What is the difference between the Gross enrolment ratio (%) in Pre-primary schools in 2006 and the Gross enrolment ratio (%) in Secondary schools in 2007?
Make the answer very short. -18.74. What is the difference between the Gross enrolment ratio (%) of Pre-primary schools in 2006 and the Gross enrolment ratio (%) of Tertiary schools in 2007?
Provide a short and direct response. 17.41. What is the difference between the Gross enrolment ratio (%) of Primary schools in 2006 and the Gross enrolment ratio (%) of Secondary schools in 2007?
Provide a succinct answer. 5.66. What is the difference between the Gross enrolment ratio (%) in Primary schools in 2006 and the Gross enrolment ratio (%) in Tertiary schools in 2007?
Ensure brevity in your answer.  41.82. What is the difference between the Gross enrolment ratio (%) of Secondary schools in 2006 and the Gross enrolment ratio (%) of Tertiary schools in 2007?
Offer a very short reply. 36.15. What is the difference between the Gross enrolment ratio (%) in Pre-primary schools in 2006 and the Gross enrolment ratio (%) in Primary schools in 2008?
Provide a succinct answer. -25.67. What is the difference between the Gross enrolment ratio (%) of Pre-primary schools in 2006 and the Gross enrolment ratio (%) of Secondary schools in 2008?
Offer a terse response. -19.48. What is the difference between the Gross enrolment ratio (%) of Pre-primary schools in 2006 and the Gross enrolment ratio (%) of Tertiary schools in 2008?
Offer a terse response. 16.58. What is the difference between the Gross enrolment ratio (%) in Primary schools in 2006 and the Gross enrolment ratio (%) in Secondary schools in 2008?
Your answer should be compact. 4.93. What is the difference between the Gross enrolment ratio (%) in Primary schools in 2006 and the Gross enrolment ratio (%) in Tertiary schools in 2008?
Ensure brevity in your answer.  40.99. What is the difference between the Gross enrolment ratio (%) of Secondary schools in 2006 and the Gross enrolment ratio (%) of Tertiary schools in 2008?
Offer a very short reply. 35.33. What is the difference between the Gross enrolment ratio (%) in Pre-primary schools in 2007 and the Gross enrolment ratio (%) in Primary schools in 2008?
Give a very brief answer. -24.85. What is the difference between the Gross enrolment ratio (%) of Pre-primary schools in 2007 and the Gross enrolment ratio (%) of Secondary schools in 2008?
Offer a terse response. -18.66. What is the difference between the Gross enrolment ratio (%) of Pre-primary schools in 2007 and the Gross enrolment ratio (%) of Tertiary schools in 2008?
Keep it short and to the point. 17.4. What is the difference between the Gross enrolment ratio (%) of Primary schools in 2007 and the Gross enrolment ratio (%) of Secondary schools in 2008?
Offer a very short reply. 5.79. What is the difference between the Gross enrolment ratio (%) of Primary schools in 2007 and the Gross enrolment ratio (%) of Tertiary schools in 2008?
Keep it short and to the point. 41.86. What is the difference between the Gross enrolment ratio (%) in Secondary schools in 2007 and the Gross enrolment ratio (%) in Tertiary schools in 2008?
Make the answer very short. 35.33. What is the average Gross enrolment ratio (%) of Pre-primary schools per year?
Give a very brief answer. 76.13. What is the average Gross enrolment ratio (%) of Primary schools per year?
Provide a succinct answer. 102.32. What is the average Gross enrolment ratio (%) of Secondary schools per year?
Provide a succinct answer. 96.72. What is the average Gross enrolment ratio (%) of Tertiary schools per year?
Keep it short and to the point. 57.96. In the year 2001, what is the difference between the Gross enrolment ratio (%) in Pre-primary schools and Gross enrolment ratio (%) in Primary schools?
Offer a very short reply. -29.11. In the year 2001, what is the difference between the Gross enrolment ratio (%) in Pre-primary schools and Gross enrolment ratio (%) in Secondary schools?
Make the answer very short. -23.19. In the year 2001, what is the difference between the Gross enrolment ratio (%) in Pre-primary schools and Gross enrolment ratio (%) in Tertiary schools?
Give a very brief answer. 20.69. In the year 2001, what is the difference between the Gross enrolment ratio (%) in Primary schools and Gross enrolment ratio (%) in Secondary schools?
Provide a succinct answer. 5.92. In the year 2001, what is the difference between the Gross enrolment ratio (%) in Primary schools and Gross enrolment ratio (%) in Tertiary schools?
Your response must be concise. 49.81. In the year 2001, what is the difference between the Gross enrolment ratio (%) of Secondary schools and Gross enrolment ratio (%) of Tertiary schools?
Offer a very short reply. 43.88. In the year 2002, what is the difference between the Gross enrolment ratio (%) of Pre-primary schools and Gross enrolment ratio (%) of Primary schools?
Your answer should be compact. -27.59. In the year 2002, what is the difference between the Gross enrolment ratio (%) in Pre-primary schools and Gross enrolment ratio (%) in Secondary schools?
Your answer should be compact. -22.79. In the year 2002, what is the difference between the Gross enrolment ratio (%) in Pre-primary schools and Gross enrolment ratio (%) in Tertiary schools?
Offer a very short reply. 18.5. In the year 2002, what is the difference between the Gross enrolment ratio (%) of Primary schools and Gross enrolment ratio (%) of Secondary schools?
Offer a terse response. 4.8. In the year 2002, what is the difference between the Gross enrolment ratio (%) of Primary schools and Gross enrolment ratio (%) of Tertiary schools?
Provide a short and direct response. 46.08. In the year 2002, what is the difference between the Gross enrolment ratio (%) of Secondary schools and Gross enrolment ratio (%) of Tertiary schools?
Give a very brief answer. 41.28. In the year 2003, what is the difference between the Gross enrolment ratio (%) of Pre-primary schools and Gross enrolment ratio (%) of Primary schools?
Keep it short and to the point. -27.68. In the year 2003, what is the difference between the Gross enrolment ratio (%) in Pre-primary schools and Gross enrolment ratio (%) in Secondary schools?
Provide a short and direct response. -23.23. In the year 2003, what is the difference between the Gross enrolment ratio (%) of Pre-primary schools and Gross enrolment ratio (%) of Tertiary schools?
Ensure brevity in your answer.  16.96. In the year 2003, what is the difference between the Gross enrolment ratio (%) in Primary schools and Gross enrolment ratio (%) in Secondary schools?
Offer a terse response. 4.45. In the year 2003, what is the difference between the Gross enrolment ratio (%) in Primary schools and Gross enrolment ratio (%) in Tertiary schools?
Provide a short and direct response. 44.64. In the year 2003, what is the difference between the Gross enrolment ratio (%) in Secondary schools and Gross enrolment ratio (%) in Tertiary schools?
Provide a succinct answer. 40.19. In the year 2004, what is the difference between the Gross enrolment ratio (%) in Pre-primary schools and Gross enrolment ratio (%) in Primary schools?
Offer a very short reply. -26.35. In the year 2004, what is the difference between the Gross enrolment ratio (%) in Pre-primary schools and Gross enrolment ratio (%) in Secondary schools?
Provide a succinct answer. -20.33. In the year 2004, what is the difference between the Gross enrolment ratio (%) of Pre-primary schools and Gross enrolment ratio (%) of Tertiary schools?
Your answer should be compact. 17.85. In the year 2004, what is the difference between the Gross enrolment ratio (%) in Primary schools and Gross enrolment ratio (%) in Secondary schools?
Keep it short and to the point. 6.02. In the year 2004, what is the difference between the Gross enrolment ratio (%) in Primary schools and Gross enrolment ratio (%) in Tertiary schools?
Make the answer very short. 44.2. In the year 2004, what is the difference between the Gross enrolment ratio (%) of Secondary schools and Gross enrolment ratio (%) of Tertiary schools?
Provide a short and direct response. 38.18. In the year 2005, what is the difference between the Gross enrolment ratio (%) in Pre-primary schools and Gross enrolment ratio (%) in Primary schools?
Ensure brevity in your answer.  -24.54. In the year 2005, what is the difference between the Gross enrolment ratio (%) in Pre-primary schools and Gross enrolment ratio (%) in Secondary schools?
Offer a terse response. -19.32. In the year 2005, what is the difference between the Gross enrolment ratio (%) in Pre-primary schools and Gross enrolment ratio (%) in Tertiary schools?
Keep it short and to the point. 18.31. In the year 2005, what is the difference between the Gross enrolment ratio (%) of Primary schools and Gross enrolment ratio (%) of Secondary schools?
Provide a succinct answer. 5.22. In the year 2005, what is the difference between the Gross enrolment ratio (%) in Primary schools and Gross enrolment ratio (%) in Tertiary schools?
Offer a very short reply. 42.85. In the year 2005, what is the difference between the Gross enrolment ratio (%) of Secondary schools and Gross enrolment ratio (%) of Tertiary schools?
Provide a succinct answer. 37.64. In the year 2006, what is the difference between the Gross enrolment ratio (%) in Pre-primary schools and Gross enrolment ratio (%) in Primary schools?
Your response must be concise. -24.41. In the year 2006, what is the difference between the Gross enrolment ratio (%) in Pre-primary schools and Gross enrolment ratio (%) in Secondary schools?
Provide a short and direct response. -18.74. In the year 2006, what is the difference between the Gross enrolment ratio (%) of Pre-primary schools and Gross enrolment ratio (%) of Tertiary schools?
Provide a short and direct response. 18.01. In the year 2006, what is the difference between the Gross enrolment ratio (%) of Primary schools and Gross enrolment ratio (%) of Secondary schools?
Offer a very short reply. 5.67. In the year 2006, what is the difference between the Gross enrolment ratio (%) of Primary schools and Gross enrolment ratio (%) of Tertiary schools?
Your answer should be very brief. 42.42. In the year 2006, what is the difference between the Gross enrolment ratio (%) of Secondary schools and Gross enrolment ratio (%) of Tertiary schools?
Provide a succinct answer. 36.75. In the year 2007, what is the difference between the Gross enrolment ratio (%) of Pre-primary schools and Gross enrolment ratio (%) of Primary schools?
Your answer should be very brief. -24.45. In the year 2007, what is the difference between the Gross enrolment ratio (%) in Pre-primary schools and Gross enrolment ratio (%) in Secondary schools?
Offer a very short reply. -17.92. In the year 2007, what is the difference between the Gross enrolment ratio (%) of Pre-primary schools and Gross enrolment ratio (%) of Tertiary schools?
Your answer should be very brief. 18.23. In the year 2007, what is the difference between the Gross enrolment ratio (%) in Primary schools and Gross enrolment ratio (%) in Secondary schools?
Make the answer very short. 6.53. In the year 2007, what is the difference between the Gross enrolment ratio (%) in Primary schools and Gross enrolment ratio (%) in Tertiary schools?
Provide a succinct answer. 42.68. In the year 2007, what is the difference between the Gross enrolment ratio (%) in Secondary schools and Gross enrolment ratio (%) in Tertiary schools?
Provide a short and direct response. 36.15. In the year 2008, what is the difference between the Gross enrolment ratio (%) of Pre-primary schools and Gross enrolment ratio (%) of Primary schools?
Provide a succinct answer. -25.45. In the year 2008, what is the difference between the Gross enrolment ratio (%) in Pre-primary schools and Gross enrolment ratio (%) in Secondary schools?
Your answer should be very brief. -19.26. In the year 2008, what is the difference between the Gross enrolment ratio (%) of Pre-primary schools and Gross enrolment ratio (%) of Tertiary schools?
Make the answer very short. 16.8. In the year 2008, what is the difference between the Gross enrolment ratio (%) of Primary schools and Gross enrolment ratio (%) of Secondary schools?
Your answer should be compact. 6.19. In the year 2008, what is the difference between the Gross enrolment ratio (%) in Primary schools and Gross enrolment ratio (%) in Tertiary schools?
Keep it short and to the point. 42.25. In the year 2008, what is the difference between the Gross enrolment ratio (%) in Secondary schools and Gross enrolment ratio (%) in Tertiary schools?
Offer a terse response. 36.06. What is the ratio of the Gross enrolment ratio (%) in Pre-primary schools in 2001 to that in 2002?
Make the answer very short. 0.99. What is the ratio of the Gross enrolment ratio (%) in Primary schools in 2001 to that in 2002?
Offer a terse response. 1. What is the ratio of the Gross enrolment ratio (%) of Secondary schools in 2001 to that in 2002?
Make the answer very short. 0.99. What is the ratio of the Gross enrolment ratio (%) of Tertiary schools in 2001 to that in 2002?
Provide a short and direct response. 0.94. What is the ratio of the Gross enrolment ratio (%) of Pre-primary schools in 2001 to that in 2003?
Offer a terse response. 0.99. What is the ratio of the Gross enrolment ratio (%) in Primary schools in 2001 to that in 2003?
Provide a short and direct response. 1. What is the ratio of the Gross enrolment ratio (%) of Tertiary schools in 2001 to that in 2003?
Offer a very short reply. 0.92. What is the ratio of the Gross enrolment ratio (%) of Pre-primary schools in 2001 to that in 2004?
Provide a succinct answer. 0.97. What is the ratio of the Gross enrolment ratio (%) of Secondary schools in 2001 to that in 2004?
Your answer should be compact. 1.01. What is the ratio of the Gross enrolment ratio (%) of Tertiary schools in 2001 to that in 2004?
Your response must be concise. 0.91. What is the ratio of the Gross enrolment ratio (%) of Pre-primary schools in 2001 to that in 2005?
Keep it short and to the point. 0.95. What is the ratio of the Gross enrolment ratio (%) of Primary schools in 2001 to that in 2005?
Your response must be concise. 1.01. What is the ratio of the Gross enrolment ratio (%) of Secondary schools in 2001 to that in 2005?
Provide a succinct answer. 1. What is the ratio of the Gross enrolment ratio (%) in Tertiary schools in 2001 to that in 2005?
Make the answer very short. 0.9. What is the ratio of the Gross enrolment ratio (%) of Pre-primary schools in 2001 to that in 2006?
Keep it short and to the point. 0.95. What is the ratio of the Gross enrolment ratio (%) in Primary schools in 2001 to that in 2006?
Provide a succinct answer. 1.01. What is the ratio of the Gross enrolment ratio (%) of Tertiary schools in 2001 to that in 2006?
Provide a short and direct response. 0.89. What is the ratio of the Gross enrolment ratio (%) in Pre-primary schools in 2001 to that in 2007?
Keep it short and to the point. 0.94. What is the ratio of the Gross enrolment ratio (%) in Primary schools in 2001 to that in 2007?
Ensure brevity in your answer.  1. What is the ratio of the Gross enrolment ratio (%) of Secondary schools in 2001 to that in 2007?
Ensure brevity in your answer.  1. What is the ratio of the Gross enrolment ratio (%) of Tertiary schools in 2001 to that in 2007?
Ensure brevity in your answer.  0.88. What is the ratio of the Gross enrolment ratio (%) in Pre-primary schools in 2001 to that in 2008?
Offer a very short reply. 0.95. What is the ratio of the Gross enrolment ratio (%) of Secondary schools in 2001 to that in 2008?
Ensure brevity in your answer.  1. What is the ratio of the Gross enrolment ratio (%) of Tertiary schools in 2001 to that in 2008?
Keep it short and to the point. 0.87. What is the ratio of the Gross enrolment ratio (%) in Tertiary schools in 2002 to that in 2003?
Make the answer very short. 0.97. What is the ratio of the Gross enrolment ratio (%) of Pre-primary schools in 2002 to that in 2004?
Keep it short and to the point. 0.98. What is the ratio of the Gross enrolment ratio (%) of Secondary schools in 2002 to that in 2004?
Provide a succinct answer. 1.01. What is the ratio of the Gross enrolment ratio (%) in Tertiary schools in 2002 to that in 2004?
Your answer should be compact. 0.97. What is the ratio of the Gross enrolment ratio (%) of Pre-primary schools in 2002 to that in 2005?
Your answer should be compact. 0.97. What is the ratio of the Gross enrolment ratio (%) in Secondary schools in 2002 to that in 2005?
Give a very brief answer. 1.01. What is the ratio of the Gross enrolment ratio (%) of Tertiary schools in 2002 to that in 2005?
Make the answer very short. 0.95. What is the ratio of the Gross enrolment ratio (%) in Pre-primary schools in 2002 to that in 2006?
Offer a terse response. 0.96. What is the ratio of the Gross enrolment ratio (%) of Primary schools in 2002 to that in 2006?
Keep it short and to the point. 1. What is the ratio of the Gross enrolment ratio (%) in Secondary schools in 2002 to that in 2006?
Offer a terse response. 1.01. What is the ratio of the Gross enrolment ratio (%) in Tertiary schools in 2002 to that in 2006?
Provide a succinct answer. 0.94. What is the ratio of the Gross enrolment ratio (%) in Pre-primary schools in 2002 to that in 2007?
Make the answer very short. 0.95. What is the ratio of the Gross enrolment ratio (%) in Primary schools in 2002 to that in 2007?
Offer a very short reply. 0.99. What is the ratio of the Gross enrolment ratio (%) in Secondary schools in 2002 to that in 2007?
Provide a short and direct response. 1.01. What is the ratio of the Gross enrolment ratio (%) in Tertiary schools in 2002 to that in 2007?
Provide a succinct answer. 0.93. What is the ratio of the Gross enrolment ratio (%) in Pre-primary schools in 2002 to that in 2008?
Your answer should be compact. 0.96. What is the ratio of the Gross enrolment ratio (%) in Secondary schools in 2002 to that in 2008?
Ensure brevity in your answer.  1. What is the ratio of the Gross enrolment ratio (%) in Tertiary schools in 2002 to that in 2008?
Provide a succinct answer. 0.92. What is the ratio of the Gross enrolment ratio (%) of Pre-primary schools in 2003 to that in 2004?
Provide a succinct answer. 0.98. What is the ratio of the Gross enrolment ratio (%) in Primary schools in 2003 to that in 2004?
Keep it short and to the point. 1. What is the ratio of the Gross enrolment ratio (%) in Secondary schools in 2003 to that in 2004?
Your answer should be compact. 1.02. What is the ratio of the Gross enrolment ratio (%) in Tertiary schools in 2003 to that in 2004?
Offer a terse response. 1. What is the ratio of the Gross enrolment ratio (%) of Pre-primary schools in 2003 to that in 2005?
Keep it short and to the point. 0.97. What is the ratio of the Gross enrolment ratio (%) of Primary schools in 2003 to that in 2005?
Offer a terse response. 1.01. What is the ratio of the Gross enrolment ratio (%) in Secondary schools in 2003 to that in 2005?
Offer a terse response. 1.01. What is the ratio of the Gross enrolment ratio (%) in Tertiary schools in 2003 to that in 2005?
Your answer should be compact. 0.98. What is the ratio of the Gross enrolment ratio (%) of Pre-primary schools in 2003 to that in 2006?
Your answer should be very brief. 0.96. What is the ratio of the Gross enrolment ratio (%) of Secondary schools in 2003 to that in 2006?
Offer a terse response. 1.02. What is the ratio of the Gross enrolment ratio (%) of Tertiary schools in 2003 to that in 2006?
Provide a short and direct response. 0.97. What is the ratio of the Gross enrolment ratio (%) of Pre-primary schools in 2003 to that in 2007?
Ensure brevity in your answer.  0.95. What is the ratio of the Gross enrolment ratio (%) of Secondary schools in 2003 to that in 2007?
Offer a very short reply. 1.02. What is the ratio of the Gross enrolment ratio (%) in Tertiary schools in 2003 to that in 2007?
Provide a succinct answer. 0.96. What is the ratio of the Gross enrolment ratio (%) in Pre-primary schools in 2003 to that in 2008?
Offer a terse response. 0.96. What is the ratio of the Gross enrolment ratio (%) in Primary schools in 2003 to that in 2008?
Provide a succinct answer. 0.99. What is the ratio of the Gross enrolment ratio (%) of Secondary schools in 2003 to that in 2008?
Keep it short and to the point. 1.01. What is the ratio of the Gross enrolment ratio (%) of Tertiary schools in 2003 to that in 2008?
Make the answer very short. 0.95. What is the ratio of the Gross enrolment ratio (%) of Pre-primary schools in 2004 to that in 2005?
Provide a succinct answer. 0.98. What is the ratio of the Gross enrolment ratio (%) in Primary schools in 2004 to that in 2005?
Keep it short and to the point. 1. What is the ratio of the Gross enrolment ratio (%) in Secondary schools in 2004 to that in 2005?
Your answer should be very brief. 1. What is the ratio of the Gross enrolment ratio (%) in Tertiary schools in 2004 to that in 2005?
Offer a very short reply. 0.98. What is the ratio of the Gross enrolment ratio (%) in Pre-primary schools in 2004 to that in 2006?
Offer a terse response. 0.98. What is the ratio of the Gross enrolment ratio (%) of Primary schools in 2004 to that in 2006?
Give a very brief answer. 1. What is the ratio of the Gross enrolment ratio (%) of Tertiary schools in 2004 to that in 2006?
Provide a succinct answer. 0.97. What is the ratio of the Gross enrolment ratio (%) in Pre-primary schools in 2004 to that in 2007?
Provide a succinct answer. 0.97. What is the ratio of the Gross enrolment ratio (%) in Secondary schools in 2004 to that in 2007?
Offer a terse response. 1. What is the ratio of the Gross enrolment ratio (%) of Tertiary schools in 2004 to that in 2007?
Provide a succinct answer. 0.96. What is the ratio of the Gross enrolment ratio (%) in Pre-primary schools in 2004 to that in 2008?
Provide a short and direct response. 0.97. What is the ratio of the Gross enrolment ratio (%) of Secondary schools in 2004 to that in 2008?
Make the answer very short. 0.99. What is the ratio of the Gross enrolment ratio (%) in Tertiary schools in 2004 to that in 2008?
Make the answer very short. 0.95. What is the ratio of the Gross enrolment ratio (%) in Pre-primary schools in 2005 to that in 2006?
Keep it short and to the point. 1. What is the ratio of the Gross enrolment ratio (%) of Secondary schools in 2005 to that in 2006?
Provide a succinct answer. 1. What is the ratio of the Gross enrolment ratio (%) in Pre-primary schools in 2005 to that in 2007?
Offer a very short reply. 0.99. What is the ratio of the Gross enrolment ratio (%) in Tertiary schools in 2005 to that in 2007?
Provide a succinct answer. 0.98. What is the ratio of the Gross enrolment ratio (%) in Primary schools in 2005 to that in 2008?
Give a very brief answer. 0.99. What is the ratio of the Gross enrolment ratio (%) of Secondary schools in 2005 to that in 2008?
Offer a very short reply. 1. What is the ratio of the Gross enrolment ratio (%) in Tertiary schools in 2005 to that in 2008?
Your answer should be very brief. 0.97. What is the ratio of the Gross enrolment ratio (%) of Pre-primary schools in 2006 to that in 2008?
Make the answer very short. 1. What is the ratio of the Gross enrolment ratio (%) in Tertiary schools in 2006 to that in 2008?
Keep it short and to the point. 0.98. What is the ratio of the Gross enrolment ratio (%) of Pre-primary schools in 2007 to that in 2008?
Your response must be concise. 1.01. What is the ratio of the Gross enrolment ratio (%) of Primary schools in 2007 to that in 2008?
Provide a succinct answer. 1. What is the ratio of the Gross enrolment ratio (%) in Tertiary schools in 2007 to that in 2008?
Your response must be concise. 0.99. What is the difference between the highest and the second highest Gross enrolment ratio (%) of Pre-primary schools?
Provide a succinct answer. 0.6. What is the difference between the highest and the second highest Gross enrolment ratio (%) of Primary schools?
Offer a very short reply. 0.4. What is the difference between the highest and the second highest Gross enrolment ratio (%) of Secondary schools?
Your answer should be compact. 0.48. What is the difference between the highest and the second highest Gross enrolment ratio (%) of Tertiary schools?
Keep it short and to the point. 0.82. What is the difference between the highest and the lowest Gross enrolment ratio (%) in Pre-primary schools?
Your answer should be very brief. 4.84. What is the difference between the highest and the lowest Gross enrolment ratio (%) in Primary schools?
Give a very brief answer. 1.45. What is the difference between the highest and the lowest Gross enrolment ratio (%) of Secondary schools?
Offer a very short reply. 1.77. What is the difference between the highest and the lowest Gross enrolment ratio (%) in Tertiary schools?
Ensure brevity in your answer.  8.12. 